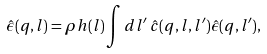Convert formula to latex. <formula><loc_0><loc_0><loc_500><loc_500>\hat { \epsilon } ( { q } , l ) = \rho h ( l ) \int d l ^ { \prime } \, \hat { c } ( { q } , l , l ^ { \prime } ) \hat { \epsilon } ( { q } , l ^ { \prime } ) ,</formula> 